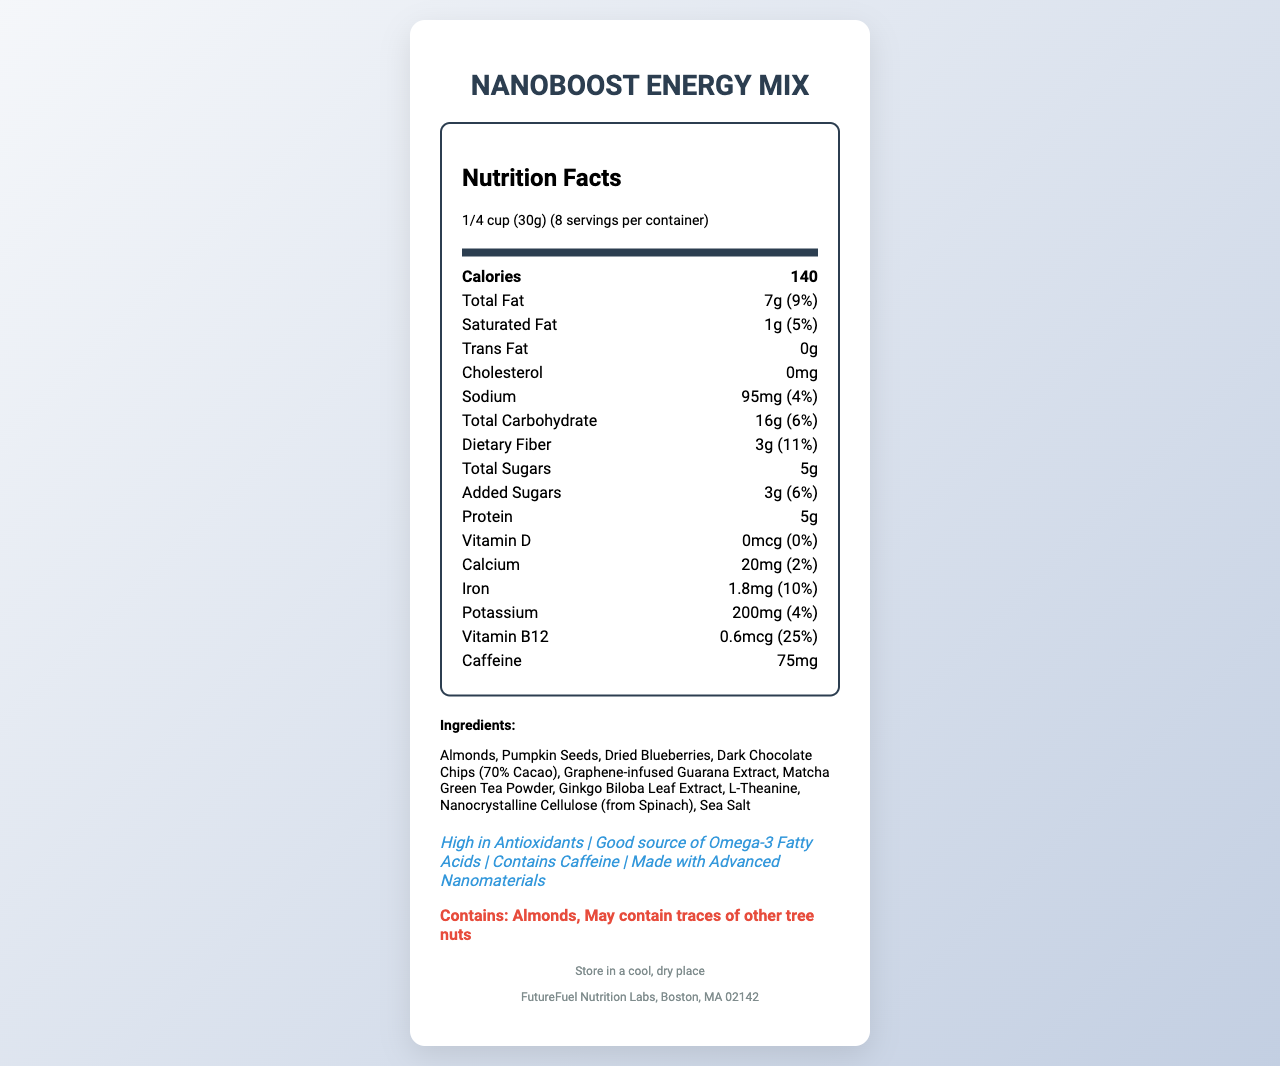what is the serving size of the NanoBoost Energy Mix? The serving size is explicitly specified in the nutrition label as 1/4 cup (30g).
Answer: 1/4 cup (30g) how many calories are there per serving? The label shows that each serving contains 140 calories.
Answer: 140 what percentage of the daily value of vitamin B12 does one serving contain? The nutrition label states that one serving provides 0.6mcg of vitamin B12, which is 25% of the daily value.
Answer: 25% how much protein is in one serving? The label indicates that one serving contains 5g of protein.
Answer: 5g which ingredient is infused with graphene? The ingredients list includes "Graphene-infused Guarana Extract."
Answer: Guarana Extract how much added sugar does the product contain per serving? The label specifies that there are 3g of added sugars per serving.
Answer: 3g which of the following claims is not listed on the document? A. High in Antioxidants B. Good source of Omega-3 Fatty Acids C. Gluten-Free D. Contains Caffeine The label lists the claims "High in Antioxidants," "Good source of Omega-3 Fatty Acids," and "Contains Caffeine," but not "Gluten-Free."
Answer: C. Gluten-Free how many servings are there per container of NanoBoost Energy Mix? A. 5 B. 8 C. 10 D. 12 The document states there are 8 servings per container.
Answer: B. 8 is there any trans fat in this product? The nutrition label shows 0g of trans fat.
Answer: No briefly summarize the main idea of the document. The document provides an overview of the nutritional content and ingredients, along with storage instructions and manufacturer details.
Answer: The document is a nutrition facts label for NanoBoost Energy Mix, detailing its serving size, calories, nutrient contents, ingredients, allergens, and health claims. what is the main source of caffeine in the NanoBoost Energy Mix? The document lists caffeine content but does not specify which ingredient is the main source of the caffeine.
Answer: Not enough information 